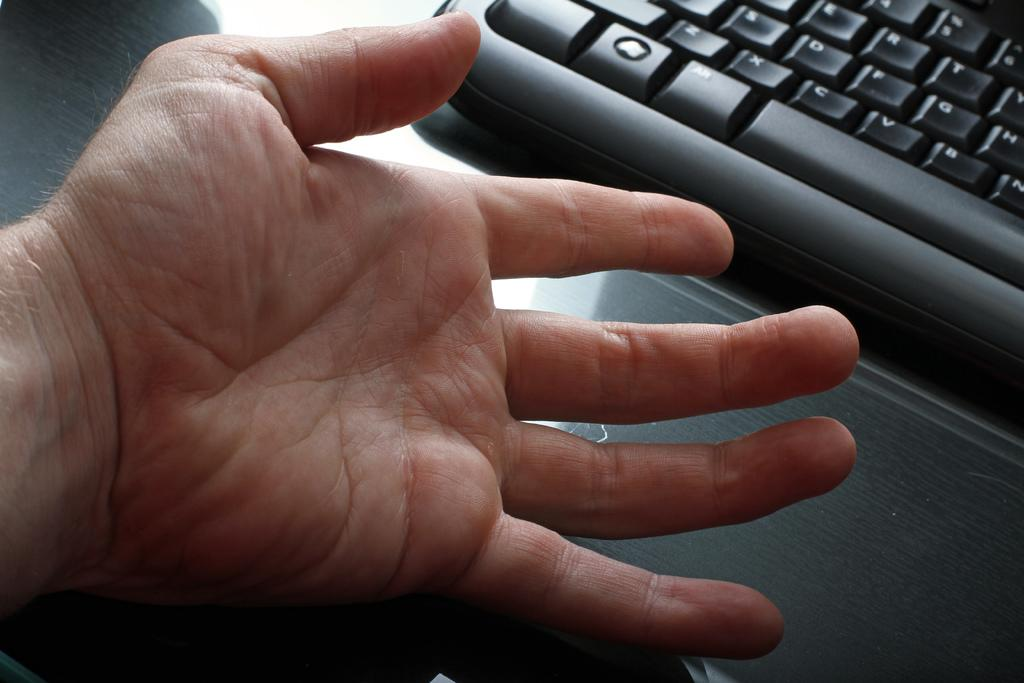<image>
Provide a brief description of the given image. The black keyboard has several keys including c, v and b. 